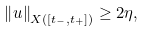Convert formula to latex. <formula><loc_0><loc_0><loc_500><loc_500>\left \| u \right \| _ { X ( [ t _ { - } , t _ { + } ] ) } \geq 2 \eta ,</formula> 